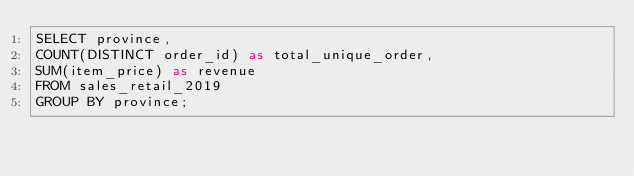<code> <loc_0><loc_0><loc_500><loc_500><_SQL_>SELECT province,
COUNT(DISTINCT order_id) as total_unique_order,
SUM(item_price) as revenue
FROM sales_retail_2019
GROUP BY province;</code> 